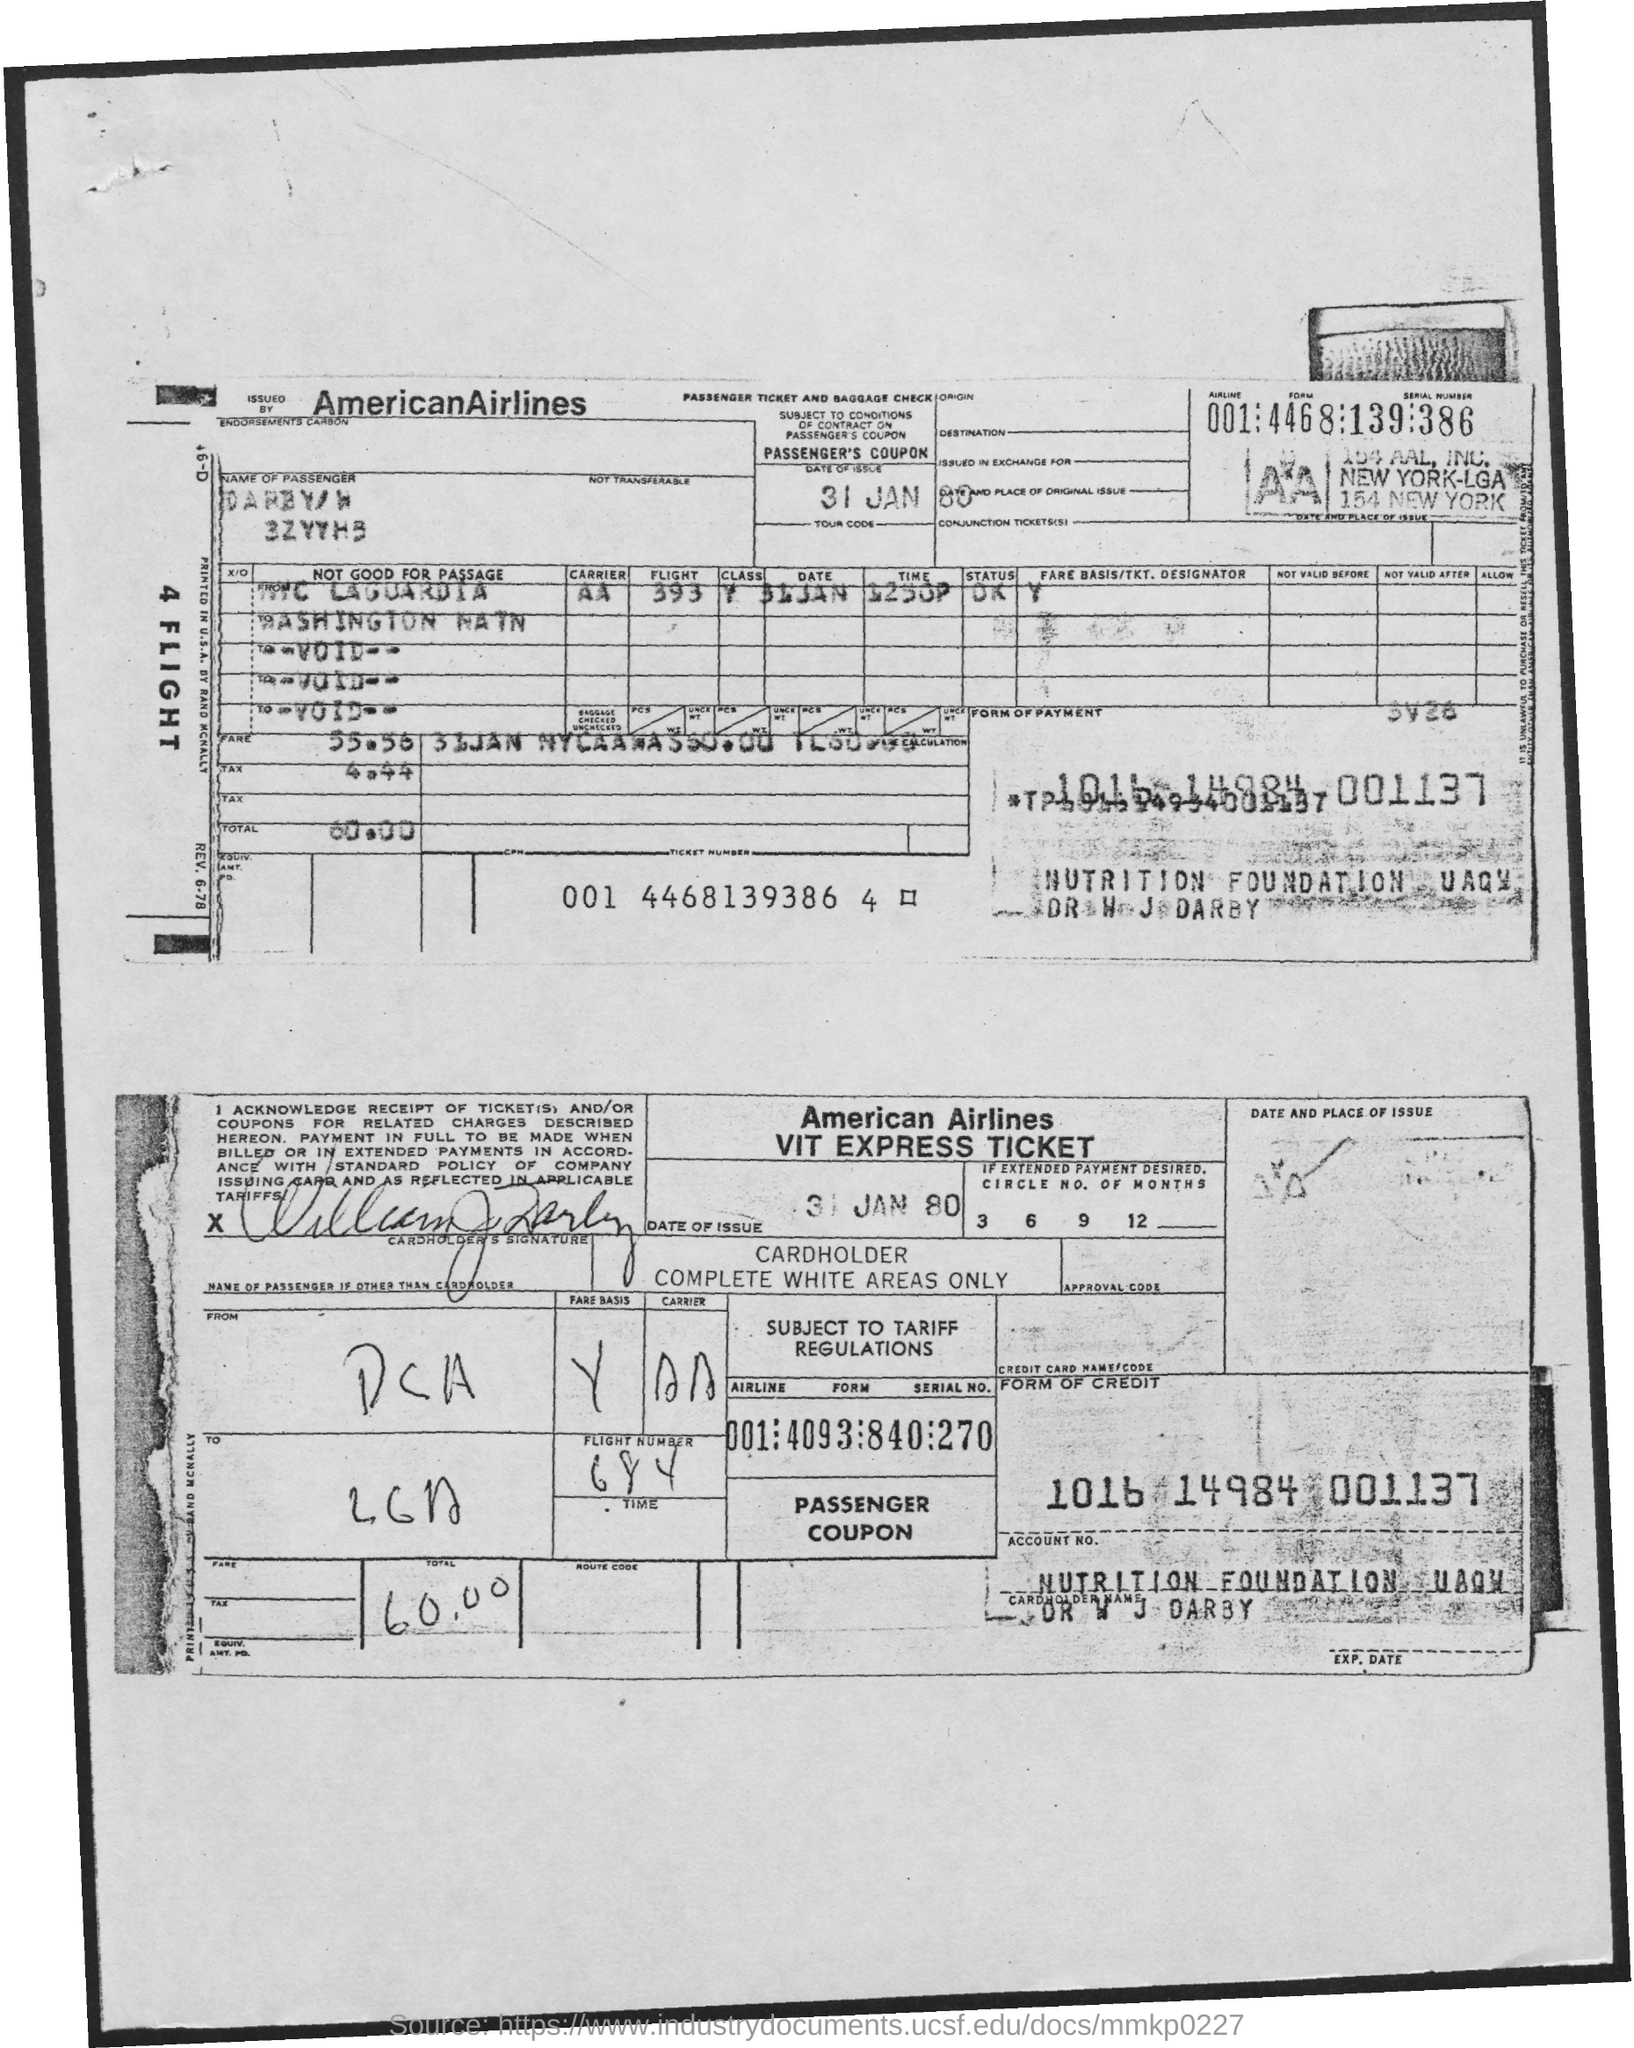Give some essential details in this illustration. Please provide the flight number, which is 684. The total amount is 60.00. The tax amount is 4.44... The fare is 55.56... The date of the issue is January 31, 1980. 